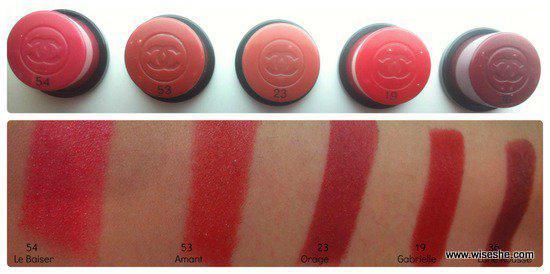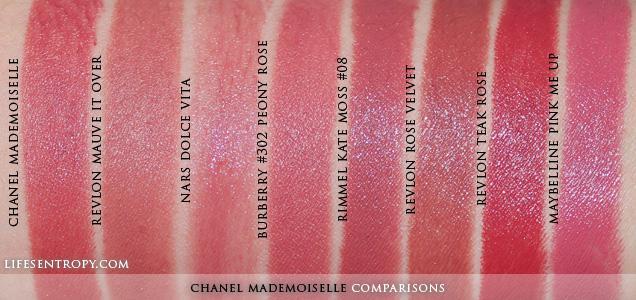The first image is the image on the left, the second image is the image on the right. Examine the images to the left and right. Is the description "An image shows a row of lipstick pots above a row of lipstick streaks on human skin." accurate? Answer yes or no. Yes. 